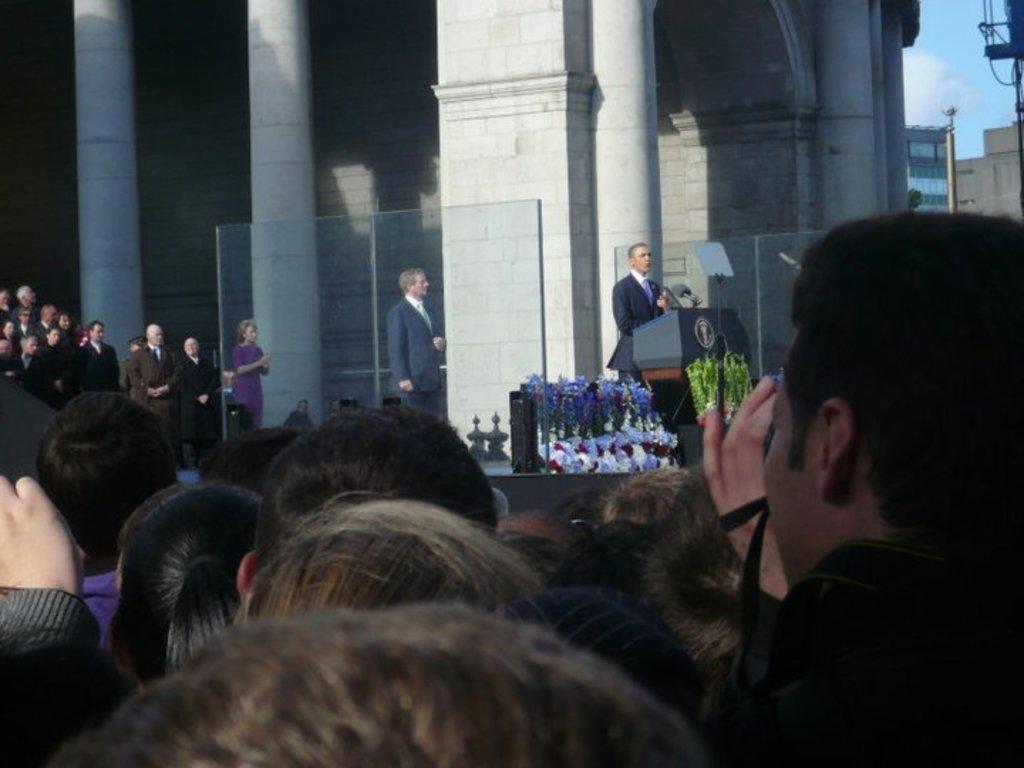In one or two sentences, can you explain what this image depicts? In this image I can see few standing. In-front of these people I can see few more people wearing different color dresses. And I can see one person is standing in-front of the podium and the person is wearing the blazer. In the back I can see the building. To the side I can see the clouds and the blue sky. 